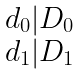Convert formula to latex. <formula><loc_0><loc_0><loc_500><loc_500>\begin{matrix} d _ { 0 } | D _ { 0 } \\ d _ { 1 } | D _ { 1 } \end{matrix}</formula> 